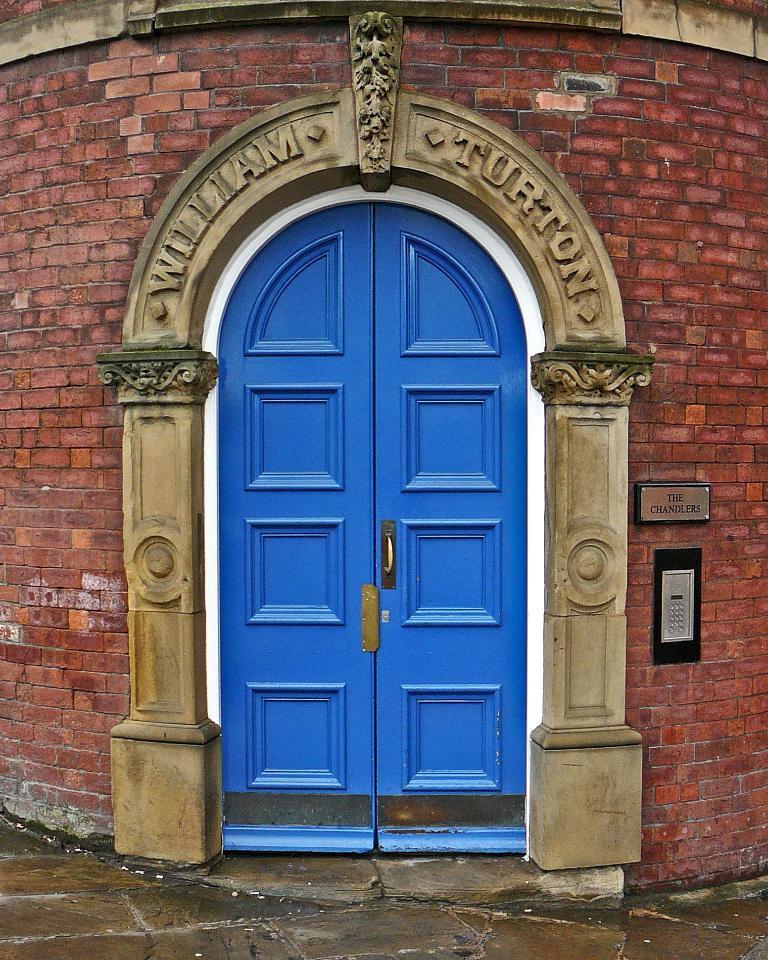How would you summarize this image in a sentence or two? In this image we can see a building, on the building we can see a board with some text and another object, also we can see the blue color doors. 